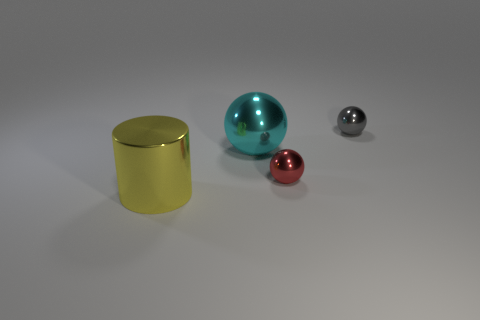How many things are either objects in front of the cyan ball or tiny metallic cylinders?
Ensure brevity in your answer.  2. What size is the cyan sphere that is the same material as the tiny gray sphere?
Your response must be concise. Large. There is a yellow object; does it have the same size as the metallic ball in front of the big cyan thing?
Provide a short and direct response. No. The metal sphere that is both on the right side of the big metallic sphere and in front of the gray ball is what color?
Keep it short and to the point. Red. How many objects are either spheres to the left of the tiny red sphere or metal things that are in front of the cyan object?
Provide a short and direct response. 3. There is a big thing right of the yellow metal object to the left of the large cyan thing to the left of the gray sphere; what color is it?
Give a very brief answer. Cyan. Are there any other tiny metallic things that have the same shape as the yellow thing?
Give a very brief answer. No. How many yellow matte objects are there?
Your answer should be very brief. 0. The gray thing is what shape?
Make the answer very short. Sphere. How many balls have the same size as the yellow object?
Your answer should be compact. 1. 